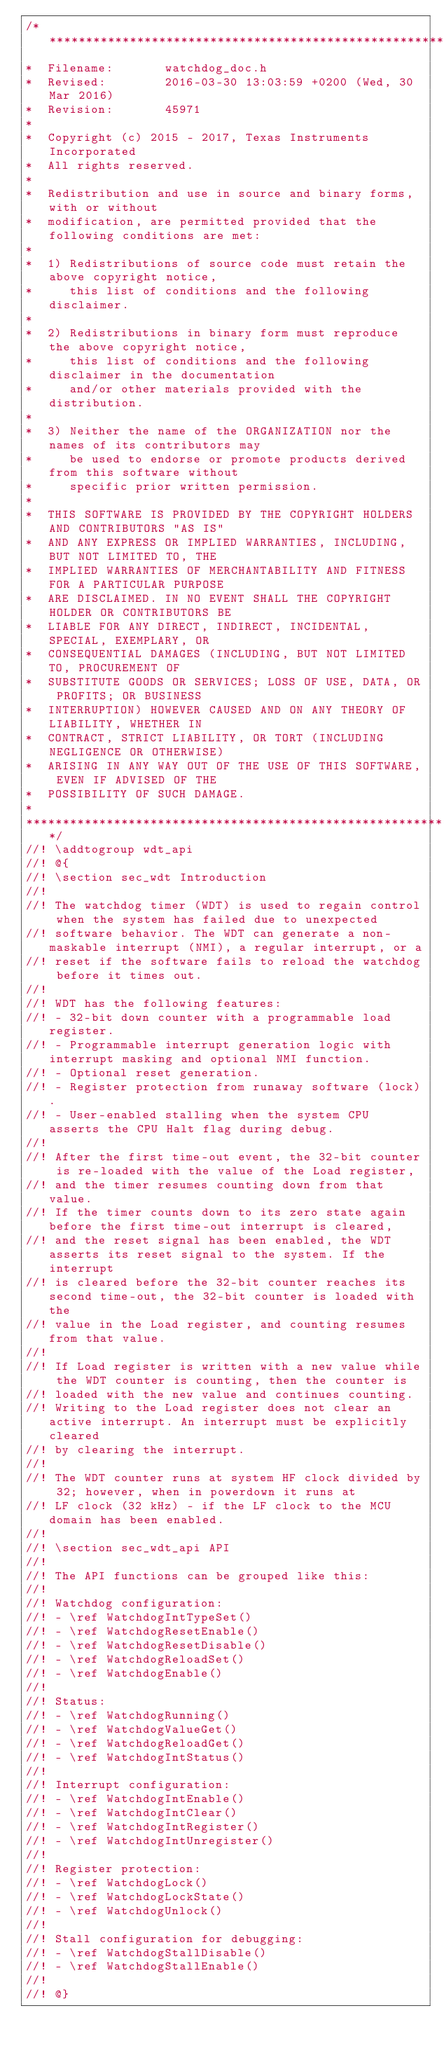<code> <loc_0><loc_0><loc_500><loc_500><_C_>/******************************************************************************
*  Filename:       watchdog_doc.h
*  Revised:        2016-03-30 13:03:59 +0200 (Wed, 30 Mar 2016)
*  Revision:       45971
*
*  Copyright (c) 2015 - 2017, Texas Instruments Incorporated
*  All rights reserved.
*
*  Redistribution and use in source and binary forms, with or without
*  modification, are permitted provided that the following conditions are met:
*
*  1) Redistributions of source code must retain the above copyright notice,
*     this list of conditions and the following disclaimer.
*
*  2) Redistributions in binary form must reproduce the above copyright notice,
*     this list of conditions and the following disclaimer in the documentation
*     and/or other materials provided with the distribution.
*
*  3) Neither the name of the ORGANIZATION nor the names of its contributors may
*     be used to endorse or promote products derived from this software without
*     specific prior written permission.
*
*  THIS SOFTWARE IS PROVIDED BY THE COPYRIGHT HOLDERS AND CONTRIBUTORS "AS IS"
*  AND ANY EXPRESS OR IMPLIED WARRANTIES, INCLUDING, BUT NOT LIMITED TO, THE
*  IMPLIED WARRANTIES OF MERCHANTABILITY AND FITNESS FOR A PARTICULAR PURPOSE
*  ARE DISCLAIMED. IN NO EVENT SHALL THE COPYRIGHT HOLDER OR CONTRIBUTORS BE
*  LIABLE FOR ANY DIRECT, INDIRECT, INCIDENTAL, SPECIAL, EXEMPLARY, OR
*  CONSEQUENTIAL DAMAGES (INCLUDING, BUT NOT LIMITED TO, PROCUREMENT OF
*  SUBSTITUTE GOODS OR SERVICES; LOSS OF USE, DATA, OR PROFITS; OR BUSINESS
*  INTERRUPTION) HOWEVER CAUSED AND ON ANY THEORY OF LIABILITY, WHETHER IN
*  CONTRACT, STRICT LIABILITY, OR TORT (INCLUDING NEGLIGENCE OR OTHERWISE)
*  ARISING IN ANY WAY OUT OF THE USE OF THIS SOFTWARE, EVEN IF ADVISED OF THE
*  POSSIBILITY OF SUCH DAMAGE.
*
******************************************************************************/
//! \addtogroup wdt_api
//! @{
//! \section sec_wdt Introduction
//!
//! The watchdog timer (WDT) is used to regain control when the system has failed due to unexpected
//! software behavior. The WDT can generate a non-maskable interrupt (NMI), a regular interrupt, or a
//! reset if the software fails to reload the watchdog before it times out.
//!
//! WDT has the following features:
//! - 32-bit down counter with a programmable load register.
//! - Programmable interrupt generation logic with interrupt masking and optional NMI function.
//! - Optional reset generation.
//! - Register protection from runaway software (lock).
//! - User-enabled stalling when the system CPU asserts the CPU Halt flag during debug.
//!
//! After the first time-out event, the 32-bit counter is re-loaded with the value of the Load register,
//! and the timer resumes counting down from that value.
//! If the timer counts down to its zero state again before the first time-out interrupt is cleared,
//! and the reset signal has been enabled, the WDT asserts its reset signal to the system. If the interrupt
//! is cleared before the 32-bit counter reaches its second time-out, the 32-bit counter is loaded with the
//! value in the Load register, and counting resumes from that value.
//!
//! If Load register is written with a new value while the WDT counter is counting, then the counter is
//! loaded with the new value and continues counting.
//! Writing to the Load register does not clear an active interrupt. An interrupt must be explicitly cleared
//! by clearing the interrupt.
//!
//! The WDT counter runs at system HF clock divided by 32; however, when in powerdown it runs at
//! LF clock (32 kHz) - if the LF clock to the MCU domain has been enabled.
//!
//! \section sec_wdt_api API
//!
//! The API functions can be grouped like this:
//!
//! Watchdog configuration:
//! - \ref WatchdogIntTypeSet()
//! - \ref WatchdogResetEnable()
//! - \ref WatchdogResetDisable()
//! - \ref WatchdogReloadSet()
//! - \ref WatchdogEnable()
//!
//! Status:
//! - \ref WatchdogRunning()
//! - \ref WatchdogValueGet()
//! - \ref WatchdogReloadGet()
//! - \ref WatchdogIntStatus()
//!
//! Interrupt configuration:
//! - \ref WatchdogIntEnable()
//! - \ref WatchdogIntClear()
//! - \ref WatchdogIntRegister()
//! - \ref WatchdogIntUnregister()
//!
//! Register protection:
//! - \ref WatchdogLock()
//! - \ref WatchdogLockState()
//! - \ref WatchdogUnlock()
//!
//! Stall configuration for debugging:
//! - \ref WatchdogStallDisable()
//! - \ref WatchdogStallEnable()
//!
//! @}
</code> 